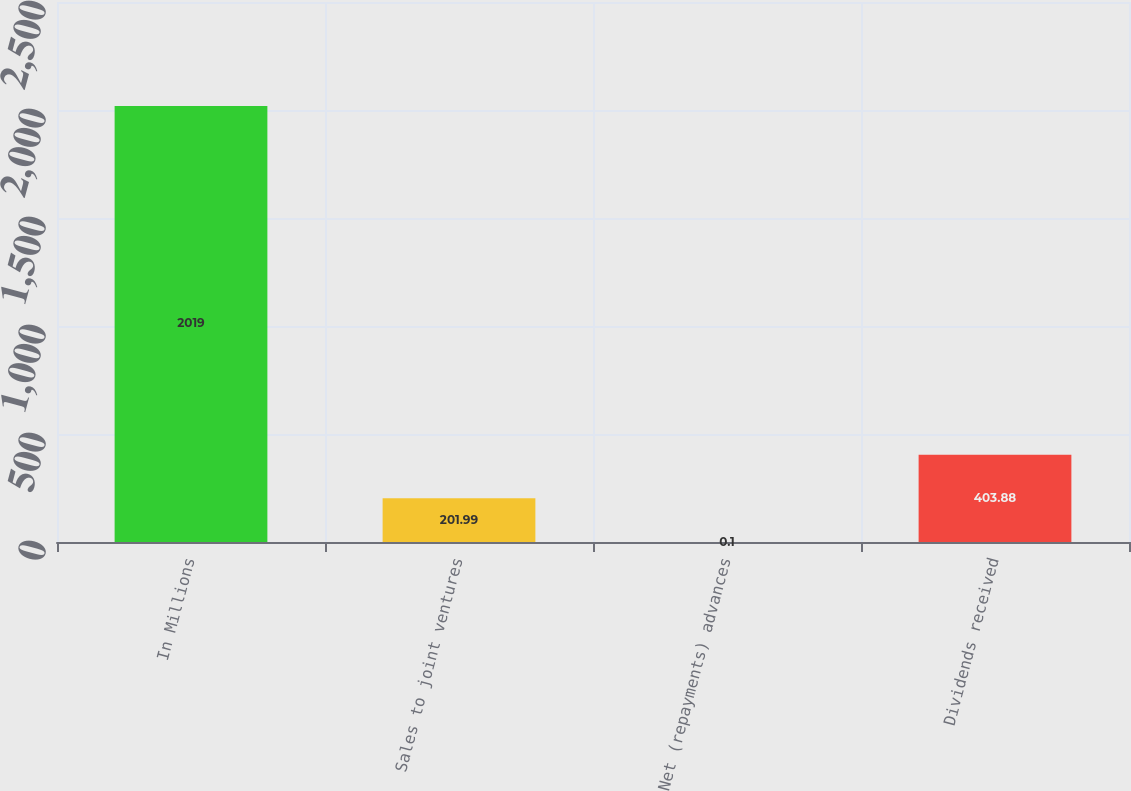Convert chart to OTSL. <chart><loc_0><loc_0><loc_500><loc_500><bar_chart><fcel>In Millions<fcel>Sales to joint ventures<fcel>Net (repayments) advances<fcel>Dividends received<nl><fcel>2019<fcel>201.99<fcel>0.1<fcel>403.88<nl></chart> 